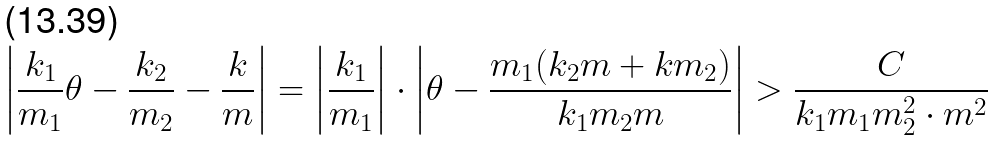Convert formula to latex. <formula><loc_0><loc_0><loc_500><loc_500>\left | \frac { k _ { 1 } } { m _ { 1 } } \theta - \frac { k _ { 2 } } { m _ { 2 } } - \frac { k } m \right | = \left | \frac { k _ { 1 } } { m _ { 1 } } \right | \cdot \left | \theta - \frac { m _ { 1 } ( k _ { 2 } m + k m _ { 2 } ) } { k _ { 1 } m _ { 2 } m } \right | > \frac { C } { k _ { 1 } m _ { 1 } m _ { 2 } ^ { 2 } \cdot m ^ { 2 } }</formula> 